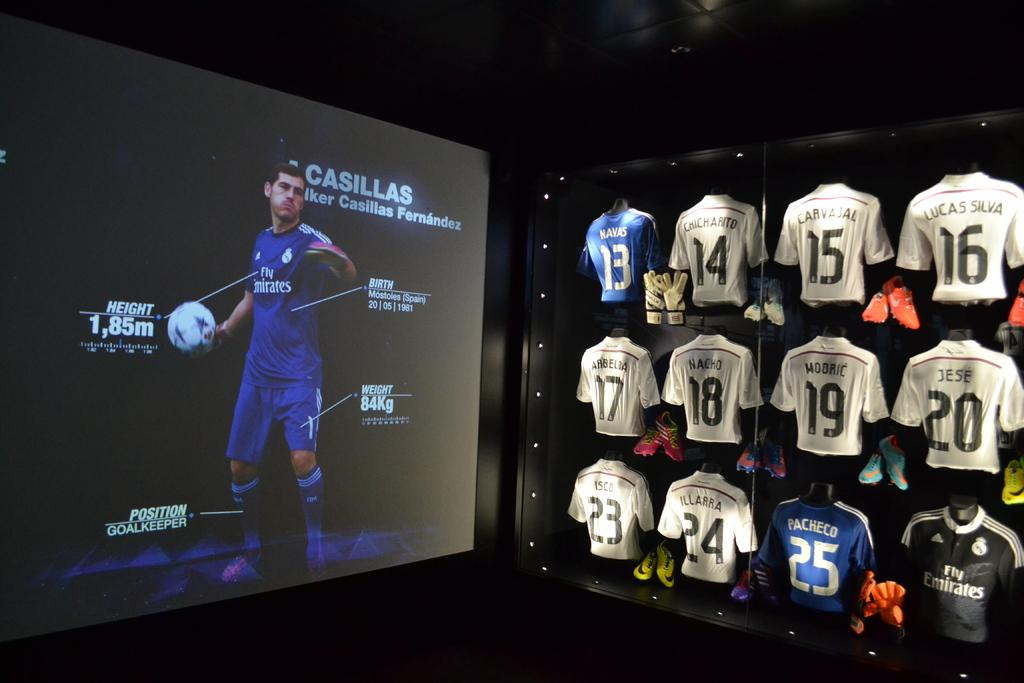<image>
Render a clear and concise summary of the photo. Jerseys displayed in a glass case and a projector showing Casillas. 